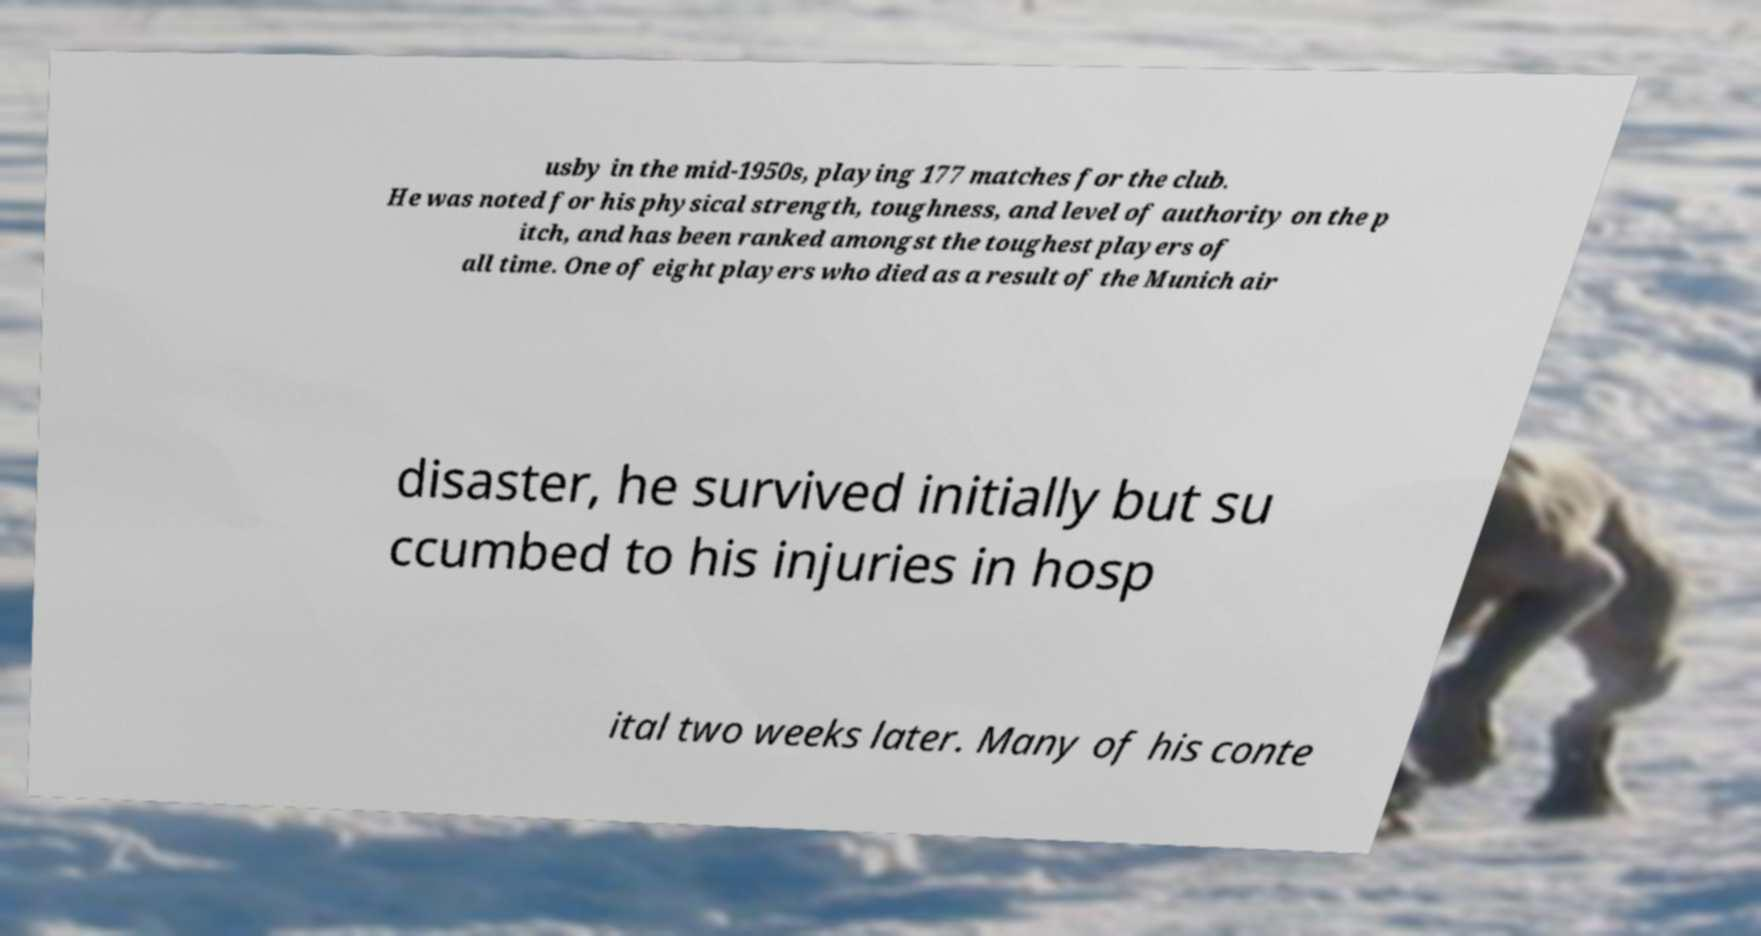Can you read and provide the text displayed in the image?This photo seems to have some interesting text. Can you extract and type it out for me? usby in the mid-1950s, playing 177 matches for the club. He was noted for his physical strength, toughness, and level of authority on the p itch, and has been ranked amongst the toughest players of all time. One of eight players who died as a result of the Munich air disaster, he survived initially but su ccumbed to his injuries in hosp ital two weeks later. Many of his conte 